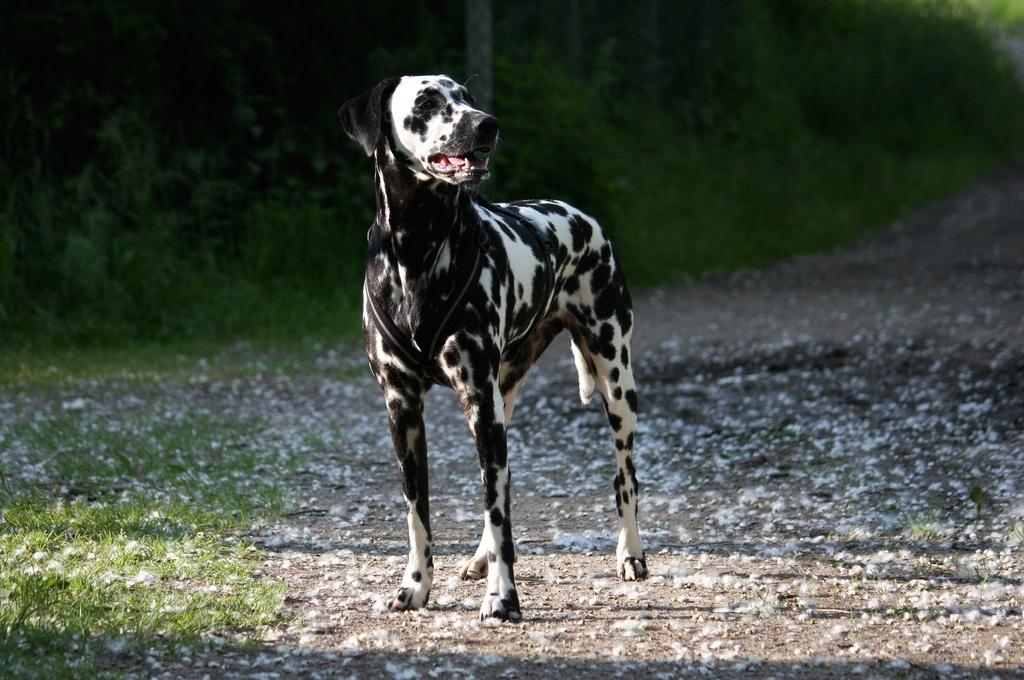What animal can be seen in the image? There is a dog in the image. What colors does the dog have? The dog is black and white. What type of vegetation is present in the image? There is grass in the bottom left of the image. How would you describe the background of the image? The background of the image is blurred. How many ladybugs are crawling on the dog in the image? There are no ladybugs present in the image; it features a dog and grass in a blurred background. 